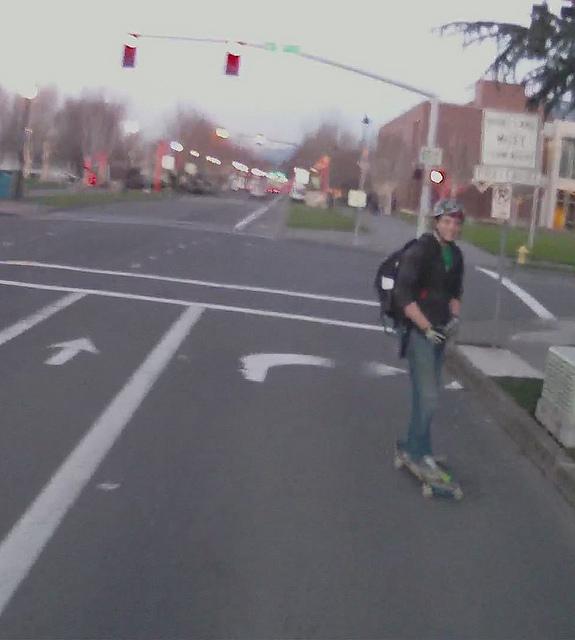What is present?
Concise answer only. Skateboarder. What is the person doing?
Write a very short answer. Skateboarding. Which way can cars in the right lane go at the intersection?
Give a very brief answer. Right. Could cars traveling the opposite direction as the skateboarder legally cross the street?
Keep it brief. Yes. What kind of place are the people in?
Concise answer only. Town. What sport is this person playing?
Concise answer only. Skateboarding. What is the man driving?
Give a very brief answer. Skateboard. 